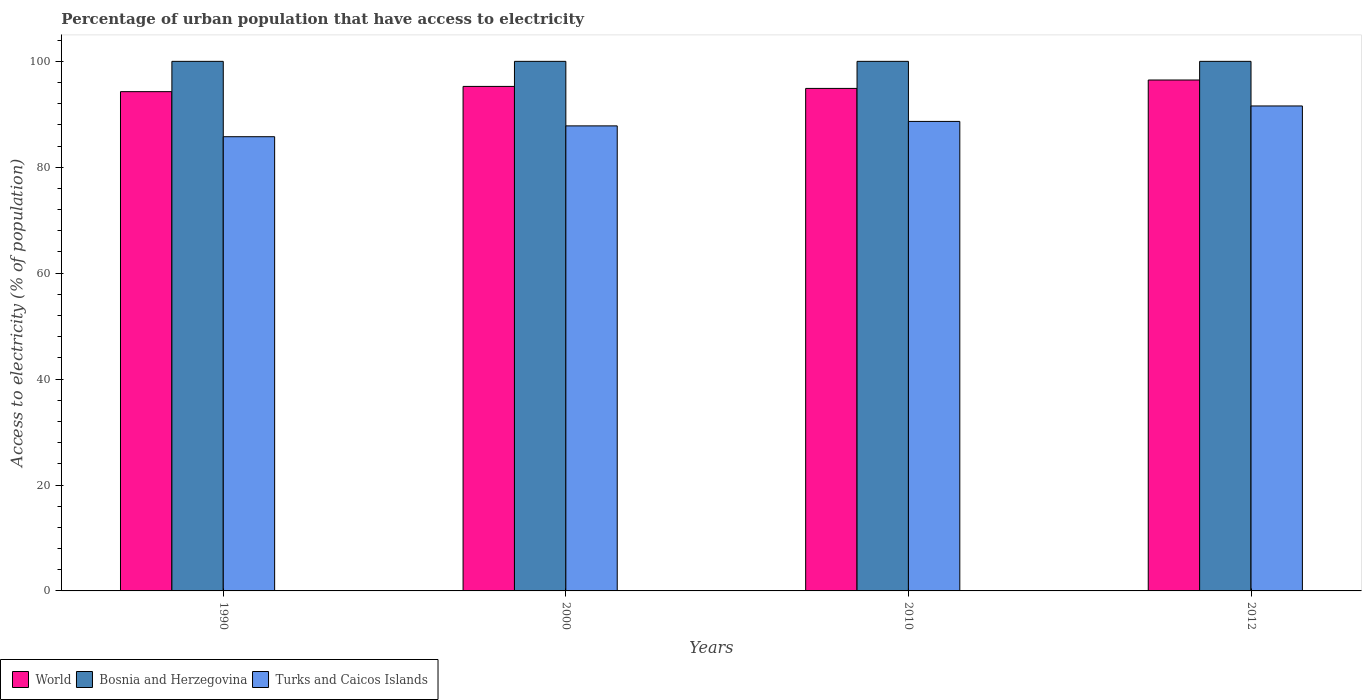How many bars are there on the 3rd tick from the left?
Your response must be concise. 3. What is the percentage of urban population that have access to electricity in Bosnia and Herzegovina in 2012?
Make the answer very short. 100. Across all years, what is the maximum percentage of urban population that have access to electricity in Bosnia and Herzegovina?
Make the answer very short. 100. Across all years, what is the minimum percentage of urban population that have access to electricity in Bosnia and Herzegovina?
Provide a succinct answer. 100. In which year was the percentage of urban population that have access to electricity in Bosnia and Herzegovina minimum?
Your response must be concise. 1990. What is the total percentage of urban population that have access to electricity in Turks and Caicos Islands in the graph?
Your response must be concise. 353.82. What is the difference between the percentage of urban population that have access to electricity in Turks and Caicos Islands in 2000 and that in 2012?
Keep it short and to the point. -3.76. What is the difference between the percentage of urban population that have access to electricity in Turks and Caicos Islands in 2000 and the percentage of urban population that have access to electricity in World in 1990?
Provide a succinct answer. -6.47. What is the average percentage of urban population that have access to electricity in World per year?
Your answer should be very brief. 95.23. In the year 2000, what is the difference between the percentage of urban population that have access to electricity in Turks and Caicos Islands and percentage of urban population that have access to electricity in World?
Make the answer very short. -7.46. What is the ratio of the percentage of urban population that have access to electricity in World in 2010 to that in 2012?
Your answer should be compact. 0.98. What does the 1st bar from the left in 1990 represents?
Ensure brevity in your answer.  World. What does the 1st bar from the right in 1990 represents?
Provide a short and direct response. Turks and Caicos Islands. How many bars are there?
Provide a succinct answer. 12. Are all the bars in the graph horizontal?
Make the answer very short. No. What is the difference between two consecutive major ticks on the Y-axis?
Your answer should be very brief. 20. Does the graph contain any zero values?
Your response must be concise. No. Does the graph contain grids?
Offer a very short reply. No. How many legend labels are there?
Ensure brevity in your answer.  3. What is the title of the graph?
Ensure brevity in your answer.  Percentage of urban population that have access to electricity. Does "Slovak Republic" appear as one of the legend labels in the graph?
Ensure brevity in your answer.  No. What is the label or title of the Y-axis?
Your answer should be compact. Access to electricity (% of population). What is the Access to electricity (% of population) in World in 1990?
Your answer should be compact. 94.28. What is the Access to electricity (% of population) in Bosnia and Herzegovina in 1990?
Keep it short and to the point. 100. What is the Access to electricity (% of population) in Turks and Caicos Islands in 1990?
Your response must be concise. 85.77. What is the Access to electricity (% of population) of World in 2000?
Make the answer very short. 95.27. What is the Access to electricity (% of population) in Turks and Caicos Islands in 2000?
Give a very brief answer. 87.81. What is the Access to electricity (% of population) in World in 2010?
Your response must be concise. 94.89. What is the Access to electricity (% of population) of Turks and Caicos Islands in 2010?
Keep it short and to the point. 88.66. What is the Access to electricity (% of population) of World in 2012?
Make the answer very short. 96.48. What is the Access to electricity (% of population) in Bosnia and Herzegovina in 2012?
Offer a very short reply. 100. What is the Access to electricity (% of population) of Turks and Caicos Islands in 2012?
Provide a succinct answer. 91.58. Across all years, what is the maximum Access to electricity (% of population) in World?
Provide a short and direct response. 96.48. Across all years, what is the maximum Access to electricity (% of population) of Bosnia and Herzegovina?
Provide a succinct answer. 100. Across all years, what is the maximum Access to electricity (% of population) in Turks and Caicos Islands?
Keep it short and to the point. 91.58. Across all years, what is the minimum Access to electricity (% of population) in World?
Give a very brief answer. 94.28. Across all years, what is the minimum Access to electricity (% of population) in Bosnia and Herzegovina?
Offer a terse response. 100. Across all years, what is the minimum Access to electricity (% of population) of Turks and Caicos Islands?
Your answer should be compact. 85.77. What is the total Access to electricity (% of population) of World in the graph?
Provide a succinct answer. 380.92. What is the total Access to electricity (% of population) of Turks and Caicos Islands in the graph?
Your answer should be very brief. 353.82. What is the difference between the Access to electricity (% of population) in World in 1990 and that in 2000?
Offer a very short reply. -0.99. What is the difference between the Access to electricity (% of population) of Bosnia and Herzegovina in 1990 and that in 2000?
Offer a very short reply. 0. What is the difference between the Access to electricity (% of population) of Turks and Caicos Islands in 1990 and that in 2000?
Offer a terse response. -2.04. What is the difference between the Access to electricity (% of population) in World in 1990 and that in 2010?
Ensure brevity in your answer.  -0.61. What is the difference between the Access to electricity (% of population) of Turks and Caicos Islands in 1990 and that in 2010?
Make the answer very short. -2.89. What is the difference between the Access to electricity (% of population) in World in 1990 and that in 2012?
Make the answer very short. -2.2. What is the difference between the Access to electricity (% of population) of Bosnia and Herzegovina in 1990 and that in 2012?
Keep it short and to the point. 0. What is the difference between the Access to electricity (% of population) in Turks and Caicos Islands in 1990 and that in 2012?
Your response must be concise. -5.81. What is the difference between the Access to electricity (% of population) of World in 2000 and that in 2010?
Give a very brief answer. 0.38. What is the difference between the Access to electricity (% of population) in Turks and Caicos Islands in 2000 and that in 2010?
Make the answer very short. -0.85. What is the difference between the Access to electricity (% of population) in World in 2000 and that in 2012?
Offer a very short reply. -1.21. What is the difference between the Access to electricity (% of population) of Turks and Caicos Islands in 2000 and that in 2012?
Give a very brief answer. -3.76. What is the difference between the Access to electricity (% of population) of World in 2010 and that in 2012?
Give a very brief answer. -1.59. What is the difference between the Access to electricity (% of population) of Bosnia and Herzegovina in 2010 and that in 2012?
Make the answer very short. 0. What is the difference between the Access to electricity (% of population) of Turks and Caicos Islands in 2010 and that in 2012?
Give a very brief answer. -2.92. What is the difference between the Access to electricity (% of population) of World in 1990 and the Access to electricity (% of population) of Bosnia and Herzegovina in 2000?
Your answer should be very brief. -5.72. What is the difference between the Access to electricity (% of population) in World in 1990 and the Access to electricity (% of population) in Turks and Caicos Islands in 2000?
Offer a terse response. 6.47. What is the difference between the Access to electricity (% of population) in Bosnia and Herzegovina in 1990 and the Access to electricity (% of population) in Turks and Caicos Islands in 2000?
Provide a succinct answer. 12.19. What is the difference between the Access to electricity (% of population) of World in 1990 and the Access to electricity (% of population) of Bosnia and Herzegovina in 2010?
Keep it short and to the point. -5.72. What is the difference between the Access to electricity (% of population) of World in 1990 and the Access to electricity (% of population) of Turks and Caicos Islands in 2010?
Make the answer very short. 5.62. What is the difference between the Access to electricity (% of population) of Bosnia and Herzegovina in 1990 and the Access to electricity (% of population) of Turks and Caicos Islands in 2010?
Your response must be concise. 11.34. What is the difference between the Access to electricity (% of population) of World in 1990 and the Access to electricity (% of population) of Bosnia and Herzegovina in 2012?
Make the answer very short. -5.72. What is the difference between the Access to electricity (% of population) in World in 1990 and the Access to electricity (% of population) in Turks and Caicos Islands in 2012?
Ensure brevity in your answer.  2.7. What is the difference between the Access to electricity (% of population) in Bosnia and Herzegovina in 1990 and the Access to electricity (% of population) in Turks and Caicos Islands in 2012?
Give a very brief answer. 8.42. What is the difference between the Access to electricity (% of population) in World in 2000 and the Access to electricity (% of population) in Bosnia and Herzegovina in 2010?
Make the answer very short. -4.73. What is the difference between the Access to electricity (% of population) of World in 2000 and the Access to electricity (% of population) of Turks and Caicos Islands in 2010?
Make the answer very short. 6.61. What is the difference between the Access to electricity (% of population) of Bosnia and Herzegovina in 2000 and the Access to electricity (% of population) of Turks and Caicos Islands in 2010?
Offer a very short reply. 11.34. What is the difference between the Access to electricity (% of population) in World in 2000 and the Access to electricity (% of population) in Bosnia and Herzegovina in 2012?
Give a very brief answer. -4.73. What is the difference between the Access to electricity (% of population) of World in 2000 and the Access to electricity (% of population) of Turks and Caicos Islands in 2012?
Ensure brevity in your answer.  3.69. What is the difference between the Access to electricity (% of population) in Bosnia and Herzegovina in 2000 and the Access to electricity (% of population) in Turks and Caicos Islands in 2012?
Provide a succinct answer. 8.42. What is the difference between the Access to electricity (% of population) in World in 2010 and the Access to electricity (% of population) in Bosnia and Herzegovina in 2012?
Keep it short and to the point. -5.11. What is the difference between the Access to electricity (% of population) in World in 2010 and the Access to electricity (% of population) in Turks and Caicos Islands in 2012?
Provide a short and direct response. 3.31. What is the difference between the Access to electricity (% of population) of Bosnia and Herzegovina in 2010 and the Access to electricity (% of population) of Turks and Caicos Islands in 2012?
Offer a very short reply. 8.42. What is the average Access to electricity (% of population) in World per year?
Keep it short and to the point. 95.23. What is the average Access to electricity (% of population) of Turks and Caicos Islands per year?
Your answer should be very brief. 88.45. In the year 1990, what is the difference between the Access to electricity (% of population) of World and Access to electricity (% of population) of Bosnia and Herzegovina?
Your response must be concise. -5.72. In the year 1990, what is the difference between the Access to electricity (% of population) of World and Access to electricity (% of population) of Turks and Caicos Islands?
Your answer should be compact. 8.51. In the year 1990, what is the difference between the Access to electricity (% of population) of Bosnia and Herzegovina and Access to electricity (% of population) of Turks and Caicos Islands?
Make the answer very short. 14.23. In the year 2000, what is the difference between the Access to electricity (% of population) in World and Access to electricity (% of population) in Bosnia and Herzegovina?
Make the answer very short. -4.73. In the year 2000, what is the difference between the Access to electricity (% of population) in World and Access to electricity (% of population) in Turks and Caicos Islands?
Ensure brevity in your answer.  7.46. In the year 2000, what is the difference between the Access to electricity (% of population) of Bosnia and Herzegovina and Access to electricity (% of population) of Turks and Caicos Islands?
Make the answer very short. 12.19. In the year 2010, what is the difference between the Access to electricity (% of population) of World and Access to electricity (% of population) of Bosnia and Herzegovina?
Make the answer very short. -5.11. In the year 2010, what is the difference between the Access to electricity (% of population) of World and Access to electricity (% of population) of Turks and Caicos Islands?
Give a very brief answer. 6.23. In the year 2010, what is the difference between the Access to electricity (% of population) of Bosnia and Herzegovina and Access to electricity (% of population) of Turks and Caicos Islands?
Your response must be concise. 11.34. In the year 2012, what is the difference between the Access to electricity (% of population) in World and Access to electricity (% of population) in Bosnia and Herzegovina?
Give a very brief answer. -3.52. In the year 2012, what is the difference between the Access to electricity (% of population) of World and Access to electricity (% of population) of Turks and Caicos Islands?
Provide a succinct answer. 4.9. In the year 2012, what is the difference between the Access to electricity (% of population) in Bosnia and Herzegovina and Access to electricity (% of population) in Turks and Caicos Islands?
Offer a very short reply. 8.42. What is the ratio of the Access to electricity (% of population) of World in 1990 to that in 2000?
Provide a short and direct response. 0.99. What is the ratio of the Access to electricity (% of population) in Turks and Caicos Islands in 1990 to that in 2000?
Keep it short and to the point. 0.98. What is the ratio of the Access to electricity (% of population) in World in 1990 to that in 2010?
Offer a terse response. 0.99. What is the ratio of the Access to electricity (% of population) of Turks and Caicos Islands in 1990 to that in 2010?
Offer a terse response. 0.97. What is the ratio of the Access to electricity (% of population) in World in 1990 to that in 2012?
Ensure brevity in your answer.  0.98. What is the ratio of the Access to electricity (% of population) of Turks and Caicos Islands in 1990 to that in 2012?
Provide a succinct answer. 0.94. What is the ratio of the Access to electricity (% of population) in Bosnia and Herzegovina in 2000 to that in 2010?
Your response must be concise. 1. What is the ratio of the Access to electricity (% of population) in World in 2000 to that in 2012?
Offer a terse response. 0.99. What is the ratio of the Access to electricity (% of population) of Turks and Caicos Islands in 2000 to that in 2012?
Your answer should be very brief. 0.96. What is the ratio of the Access to electricity (% of population) of World in 2010 to that in 2012?
Your response must be concise. 0.98. What is the ratio of the Access to electricity (% of population) of Turks and Caicos Islands in 2010 to that in 2012?
Give a very brief answer. 0.97. What is the difference between the highest and the second highest Access to electricity (% of population) in World?
Provide a succinct answer. 1.21. What is the difference between the highest and the second highest Access to electricity (% of population) of Bosnia and Herzegovina?
Ensure brevity in your answer.  0. What is the difference between the highest and the second highest Access to electricity (% of population) in Turks and Caicos Islands?
Make the answer very short. 2.92. What is the difference between the highest and the lowest Access to electricity (% of population) of World?
Give a very brief answer. 2.2. What is the difference between the highest and the lowest Access to electricity (% of population) of Turks and Caicos Islands?
Offer a terse response. 5.81. 